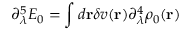Convert formula to latex. <formula><loc_0><loc_0><loc_500><loc_500>\partial _ { \lambda } ^ { 5 } E _ { 0 } = \int d { r } \delta v ( { r } ) \partial _ { \lambda } ^ { 4 } \rho _ { 0 } ( { r } )</formula> 